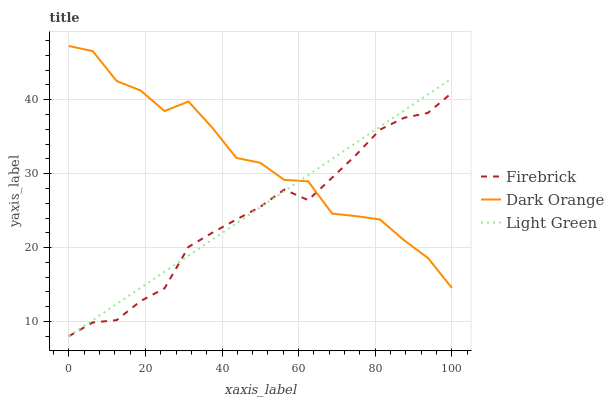Does Firebrick have the minimum area under the curve?
Answer yes or no. Yes. Does Dark Orange have the maximum area under the curve?
Answer yes or no. Yes. Does Light Green have the minimum area under the curve?
Answer yes or no. No. Does Light Green have the maximum area under the curve?
Answer yes or no. No. Is Light Green the smoothest?
Answer yes or no. Yes. Is Dark Orange the roughest?
Answer yes or no. Yes. Is Firebrick the smoothest?
Answer yes or no. No. Is Firebrick the roughest?
Answer yes or no. No. Does Dark Orange have the highest value?
Answer yes or no. Yes. Does Light Green have the highest value?
Answer yes or no. No. 